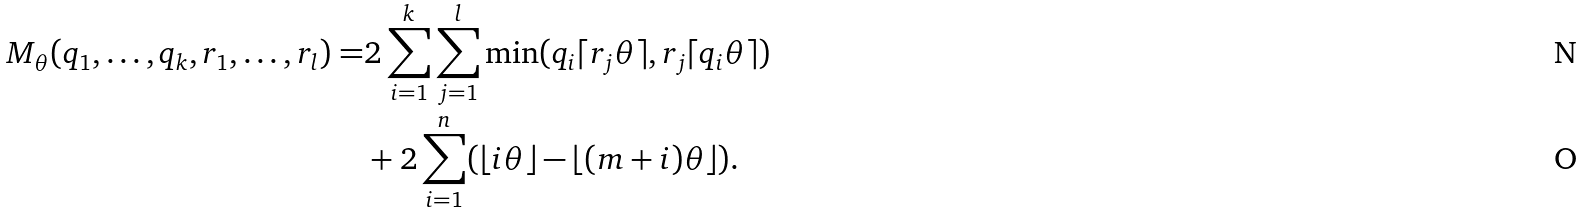Convert formula to latex. <formula><loc_0><loc_0><loc_500><loc_500>M _ { \theta } ( q _ { 1 } , \dots , q _ { k } , r _ { 1 } , \dots , r _ { l } ) = & 2 \sum _ { i = 1 } ^ { k } \sum _ { j = 1 } ^ { l } \min ( q _ { i } \lceil r _ { j } \theta \rceil , r _ { j } \lceil q _ { i } \theta \rceil ) \\ & + 2 \sum _ { i = 1 } ^ { n } ( \lfloor i \theta \rfloor - \lfloor ( m + i ) \theta \rfloor ) .</formula> 